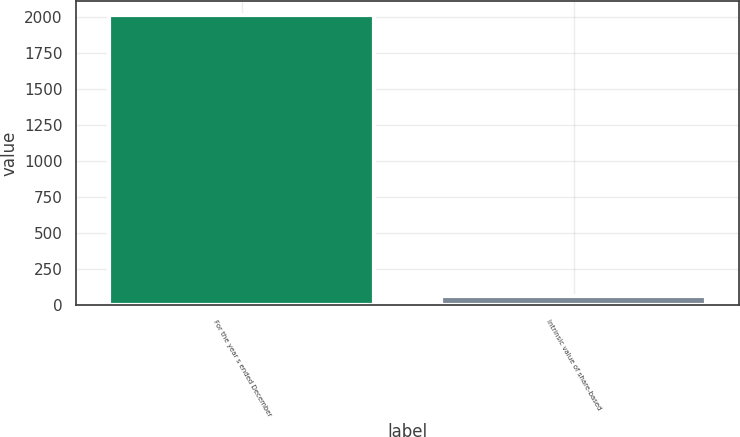<chart> <loc_0><loc_0><loc_500><loc_500><bar_chart><fcel>For the year s ended December<fcel>Intrinsic value of share-based<nl><fcel>2013<fcel>62.6<nl></chart> 